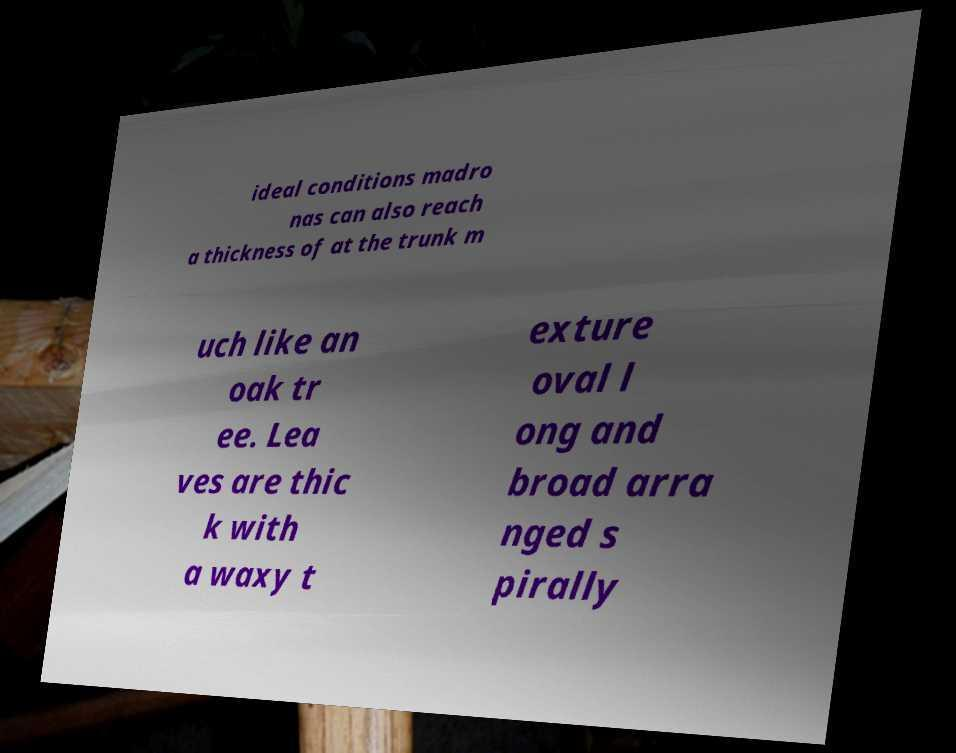What messages or text are displayed in this image? I need them in a readable, typed format. ideal conditions madro nas can also reach a thickness of at the trunk m uch like an oak tr ee. Lea ves are thic k with a waxy t exture oval l ong and broad arra nged s pirally 